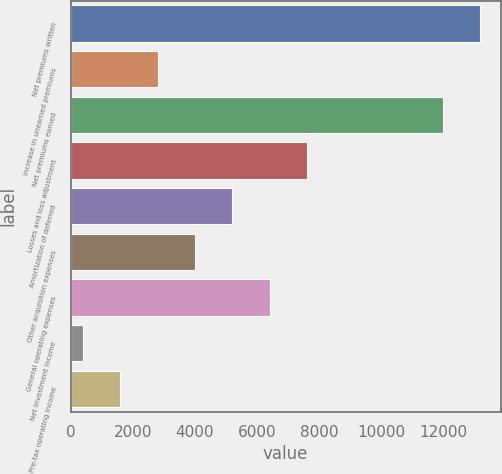Convert chart to OTSL. <chart><loc_0><loc_0><loc_500><loc_500><bar_chart><fcel>Net premiums written<fcel>Increase in unearned premiums<fcel>Net premiums earned<fcel>Losses and loss adjustment<fcel>Amortization of deferred<fcel>Other acquisition expenses<fcel>General operating expenses<fcel>Net investment income<fcel>Pre-tax operating income<nl><fcel>13171.8<fcel>2797.6<fcel>11970<fcel>7604.8<fcel>5201.2<fcel>3999.4<fcel>6403<fcel>394<fcel>1595.8<nl></chart> 